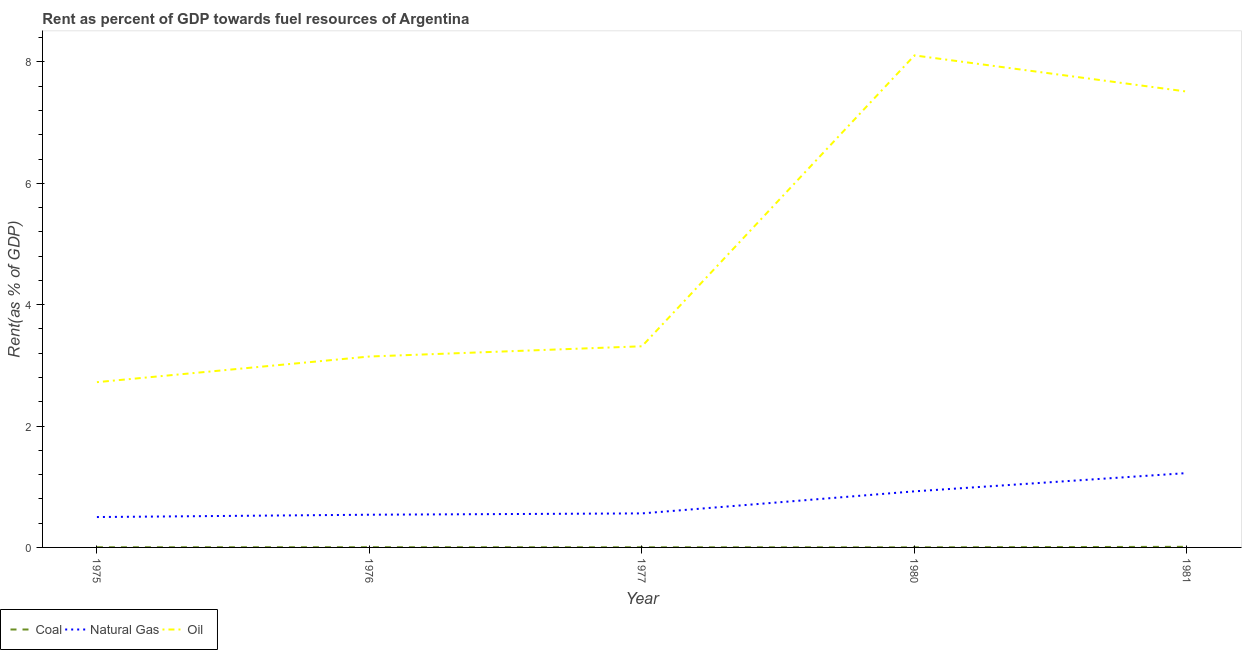What is the rent towards oil in 1981?
Offer a terse response. 7.51. Across all years, what is the maximum rent towards coal?
Offer a terse response. 0.01. Across all years, what is the minimum rent towards coal?
Ensure brevity in your answer.  0. In which year was the rent towards oil minimum?
Your answer should be very brief. 1975. What is the total rent towards coal in the graph?
Keep it short and to the point. 0.02. What is the difference between the rent towards coal in 1975 and that in 1981?
Your answer should be compact. -0.01. What is the difference between the rent towards coal in 1981 and the rent towards natural gas in 1977?
Provide a succinct answer. -0.55. What is the average rent towards oil per year?
Offer a very short reply. 4.96. In the year 1981, what is the difference between the rent towards natural gas and rent towards oil?
Your answer should be very brief. -6.29. In how many years, is the rent towards oil greater than 4.8 %?
Provide a short and direct response. 2. What is the ratio of the rent towards oil in 1977 to that in 1980?
Provide a short and direct response. 0.41. Is the difference between the rent towards oil in 1975 and 1976 greater than the difference between the rent towards coal in 1975 and 1976?
Your answer should be very brief. No. What is the difference between the highest and the second highest rent towards natural gas?
Provide a short and direct response. 0.3. What is the difference between the highest and the lowest rent towards coal?
Keep it short and to the point. 0.01. In how many years, is the rent towards coal greater than the average rent towards coal taken over all years?
Keep it short and to the point. 1. Is the sum of the rent towards natural gas in 1976 and 1980 greater than the maximum rent towards oil across all years?
Your answer should be compact. No. Does the rent towards coal monotonically increase over the years?
Offer a terse response. No. Is the rent towards coal strictly greater than the rent towards natural gas over the years?
Your response must be concise. No. How many lines are there?
Give a very brief answer. 3. What is the difference between two consecutive major ticks on the Y-axis?
Keep it short and to the point. 2. Does the graph contain any zero values?
Provide a short and direct response. No. Does the graph contain grids?
Offer a terse response. No. What is the title of the graph?
Offer a very short reply. Rent as percent of GDP towards fuel resources of Argentina. Does "Private sector" appear as one of the legend labels in the graph?
Ensure brevity in your answer.  No. What is the label or title of the X-axis?
Keep it short and to the point. Year. What is the label or title of the Y-axis?
Offer a very short reply. Rent(as % of GDP). What is the Rent(as % of GDP) in Coal in 1975?
Your answer should be compact. 0. What is the Rent(as % of GDP) of Natural Gas in 1975?
Offer a very short reply. 0.5. What is the Rent(as % of GDP) of Oil in 1975?
Offer a terse response. 2.72. What is the Rent(as % of GDP) in Coal in 1976?
Make the answer very short. 0. What is the Rent(as % of GDP) of Natural Gas in 1976?
Offer a terse response. 0.54. What is the Rent(as % of GDP) in Oil in 1976?
Provide a succinct answer. 3.15. What is the Rent(as % of GDP) of Coal in 1977?
Your response must be concise. 0. What is the Rent(as % of GDP) of Natural Gas in 1977?
Provide a short and direct response. 0.56. What is the Rent(as % of GDP) of Oil in 1977?
Give a very brief answer. 3.31. What is the Rent(as % of GDP) of Coal in 1980?
Keep it short and to the point. 0. What is the Rent(as % of GDP) in Natural Gas in 1980?
Your response must be concise. 0.92. What is the Rent(as % of GDP) in Oil in 1980?
Your response must be concise. 8.11. What is the Rent(as % of GDP) of Coal in 1981?
Ensure brevity in your answer.  0.01. What is the Rent(as % of GDP) in Natural Gas in 1981?
Make the answer very short. 1.23. What is the Rent(as % of GDP) of Oil in 1981?
Your answer should be compact. 7.51. Across all years, what is the maximum Rent(as % of GDP) of Coal?
Provide a short and direct response. 0.01. Across all years, what is the maximum Rent(as % of GDP) in Natural Gas?
Provide a short and direct response. 1.23. Across all years, what is the maximum Rent(as % of GDP) in Oil?
Give a very brief answer. 8.11. Across all years, what is the minimum Rent(as % of GDP) in Coal?
Keep it short and to the point. 0. Across all years, what is the minimum Rent(as % of GDP) of Natural Gas?
Ensure brevity in your answer.  0.5. Across all years, what is the minimum Rent(as % of GDP) of Oil?
Make the answer very short. 2.72. What is the total Rent(as % of GDP) in Coal in the graph?
Offer a terse response. 0.02. What is the total Rent(as % of GDP) in Natural Gas in the graph?
Your answer should be compact. 3.75. What is the total Rent(as % of GDP) of Oil in the graph?
Offer a very short reply. 24.8. What is the difference between the Rent(as % of GDP) of Coal in 1975 and that in 1976?
Keep it short and to the point. -0. What is the difference between the Rent(as % of GDP) of Natural Gas in 1975 and that in 1976?
Make the answer very short. -0.04. What is the difference between the Rent(as % of GDP) in Oil in 1975 and that in 1976?
Your answer should be compact. -0.42. What is the difference between the Rent(as % of GDP) of Natural Gas in 1975 and that in 1977?
Make the answer very short. -0.06. What is the difference between the Rent(as % of GDP) of Oil in 1975 and that in 1977?
Ensure brevity in your answer.  -0.59. What is the difference between the Rent(as % of GDP) in Coal in 1975 and that in 1980?
Your answer should be compact. 0. What is the difference between the Rent(as % of GDP) in Natural Gas in 1975 and that in 1980?
Keep it short and to the point. -0.42. What is the difference between the Rent(as % of GDP) of Oil in 1975 and that in 1980?
Give a very brief answer. -5.38. What is the difference between the Rent(as % of GDP) in Coal in 1975 and that in 1981?
Ensure brevity in your answer.  -0.01. What is the difference between the Rent(as % of GDP) in Natural Gas in 1975 and that in 1981?
Your response must be concise. -0.72. What is the difference between the Rent(as % of GDP) in Oil in 1975 and that in 1981?
Offer a terse response. -4.79. What is the difference between the Rent(as % of GDP) of Coal in 1976 and that in 1977?
Make the answer very short. 0. What is the difference between the Rent(as % of GDP) of Natural Gas in 1976 and that in 1977?
Provide a succinct answer. -0.02. What is the difference between the Rent(as % of GDP) in Oil in 1976 and that in 1977?
Offer a very short reply. -0.17. What is the difference between the Rent(as % of GDP) of Coal in 1976 and that in 1980?
Offer a very short reply. 0. What is the difference between the Rent(as % of GDP) of Natural Gas in 1976 and that in 1980?
Ensure brevity in your answer.  -0.39. What is the difference between the Rent(as % of GDP) of Oil in 1976 and that in 1980?
Provide a succinct answer. -4.96. What is the difference between the Rent(as % of GDP) of Coal in 1976 and that in 1981?
Provide a short and direct response. -0.01. What is the difference between the Rent(as % of GDP) in Natural Gas in 1976 and that in 1981?
Provide a short and direct response. -0.69. What is the difference between the Rent(as % of GDP) of Oil in 1976 and that in 1981?
Make the answer very short. -4.37. What is the difference between the Rent(as % of GDP) of Natural Gas in 1977 and that in 1980?
Provide a succinct answer. -0.36. What is the difference between the Rent(as % of GDP) in Oil in 1977 and that in 1980?
Your answer should be compact. -4.79. What is the difference between the Rent(as % of GDP) in Coal in 1977 and that in 1981?
Your answer should be compact. -0.01. What is the difference between the Rent(as % of GDP) in Natural Gas in 1977 and that in 1981?
Make the answer very short. -0.66. What is the difference between the Rent(as % of GDP) of Oil in 1977 and that in 1981?
Your answer should be compact. -4.2. What is the difference between the Rent(as % of GDP) of Coal in 1980 and that in 1981?
Provide a short and direct response. -0.01. What is the difference between the Rent(as % of GDP) of Natural Gas in 1980 and that in 1981?
Make the answer very short. -0.3. What is the difference between the Rent(as % of GDP) of Oil in 1980 and that in 1981?
Make the answer very short. 0.6. What is the difference between the Rent(as % of GDP) in Coal in 1975 and the Rent(as % of GDP) in Natural Gas in 1976?
Your answer should be very brief. -0.54. What is the difference between the Rent(as % of GDP) in Coal in 1975 and the Rent(as % of GDP) in Oil in 1976?
Your answer should be compact. -3.14. What is the difference between the Rent(as % of GDP) in Natural Gas in 1975 and the Rent(as % of GDP) in Oil in 1976?
Your answer should be very brief. -2.65. What is the difference between the Rent(as % of GDP) of Coal in 1975 and the Rent(as % of GDP) of Natural Gas in 1977?
Your answer should be compact. -0.56. What is the difference between the Rent(as % of GDP) of Coal in 1975 and the Rent(as % of GDP) of Oil in 1977?
Your answer should be compact. -3.31. What is the difference between the Rent(as % of GDP) of Natural Gas in 1975 and the Rent(as % of GDP) of Oil in 1977?
Offer a terse response. -2.81. What is the difference between the Rent(as % of GDP) in Coal in 1975 and the Rent(as % of GDP) in Natural Gas in 1980?
Ensure brevity in your answer.  -0.92. What is the difference between the Rent(as % of GDP) of Coal in 1975 and the Rent(as % of GDP) of Oil in 1980?
Provide a succinct answer. -8.1. What is the difference between the Rent(as % of GDP) in Natural Gas in 1975 and the Rent(as % of GDP) in Oil in 1980?
Give a very brief answer. -7.61. What is the difference between the Rent(as % of GDP) in Coal in 1975 and the Rent(as % of GDP) in Natural Gas in 1981?
Keep it short and to the point. -1.22. What is the difference between the Rent(as % of GDP) of Coal in 1975 and the Rent(as % of GDP) of Oil in 1981?
Your response must be concise. -7.51. What is the difference between the Rent(as % of GDP) in Natural Gas in 1975 and the Rent(as % of GDP) in Oil in 1981?
Provide a succinct answer. -7.01. What is the difference between the Rent(as % of GDP) in Coal in 1976 and the Rent(as % of GDP) in Natural Gas in 1977?
Make the answer very short. -0.56. What is the difference between the Rent(as % of GDP) of Coal in 1976 and the Rent(as % of GDP) of Oil in 1977?
Your answer should be compact. -3.31. What is the difference between the Rent(as % of GDP) in Natural Gas in 1976 and the Rent(as % of GDP) in Oil in 1977?
Keep it short and to the point. -2.78. What is the difference between the Rent(as % of GDP) of Coal in 1976 and the Rent(as % of GDP) of Natural Gas in 1980?
Ensure brevity in your answer.  -0.92. What is the difference between the Rent(as % of GDP) of Coal in 1976 and the Rent(as % of GDP) of Oil in 1980?
Offer a very short reply. -8.1. What is the difference between the Rent(as % of GDP) of Natural Gas in 1976 and the Rent(as % of GDP) of Oil in 1980?
Your answer should be compact. -7.57. What is the difference between the Rent(as % of GDP) of Coal in 1976 and the Rent(as % of GDP) of Natural Gas in 1981?
Your answer should be compact. -1.22. What is the difference between the Rent(as % of GDP) of Coal in 1976 and the Rent(as % of GDP) of Oil in 1981?
Offer a very short reply. -7.51. What is the difference between the Rent(as % of GDP) in Natural Gas in 1976 and the Rent(as % of GDP) in Oil in 1981?
Offer a very short reply. -6.97. What is the difference between the Rent(as % of GDP) of Coal in 1977 and the Rent(as % of GDP) of Natural Gas in 1980?
Provide a succinct answer. -0.92. What is the difference between the Rent(as % of GDP) of Coal in 1977 and the Rent(as % of GDP) of Oil in 1980?
Provide a short and direct response. -8.1. What is the difference between the Rent(as % of GDP) in Natural Gas in 1977 and the Rent(as % of GDP) in Oil in 1980?
Your response must be concise. -7.55. What is the difference between the Rent(as % of GDP) of Coal in 1977 and the Rent(as % of GDP) of Natural Gas in 1981?
Offer a very short reply. -1.22. What is the difference between the Rent(as % of GDP) of Coal in 1977 and the Rent(as % of GDP) of Oil in 1981?
Provide a short and direct response. -7.51. What is the difference between the Rent(as % of GDP) of Natural Gas in 1977 and the Rent(as % of GDP) of Oil in 1981?
Offer a terse response. -6.95. What is the difference between the Rent(as % of GDP) of Coal in 1980 and the Rent(as % of GDP) of Natural Gas in 1981?
Ensure brevity in your answer.  -1.22. What is the difference between the Rent(as % of GDP) in Coal in 1980 and the Rent(as % of GDP) in Oil in 1981?
Make the answer very short. -7.51. What is the difference between the Rent(as % of GDP) of Natural Gas in 1980 and the Rent(as % of GDP) of Oil in 1981?
Your answer should be very brief. -6.59. What is the average Rent(as % of GDP) in Coal per year?
Make the answer very short. 0. What is the average Rent(as % of GDP) of Natural Gas per year?
Ensure brevity in your answer.  0.75. What is the average Rent(as % of GDP) in Oil per year?
Provide a short and direct response. 4.96. In the year 1975, what is the difference between the Rent(as % of GDP) in Coal and Rent(as % of GDP) in Natural Gas?
Provide a short and direct response. -0.5. In the year 1975, what is the difference between the Rent(as % of GDP) of Coal and Rent(as % of GDP) of Oil?
Your answer should be very brief. -2.72. In the year 1975, what is the difference between the Rent(as % of GDP) of Natural Gas and Rent(as % of GDP) of Oil?
Keep it short and to the point. -2.22. In the year 1976, what is the difference between the Rent(as % of GDP) of Coal and Rent(as % of GDP) of Natural Gas?
Provide a short and direct response. -0.54. In the year 1976, what is the difference between the Rent(as % of GDP) of Coal and Rent(as % of GDP) of Oil?
Keep it short and to the point. -3.14. In the year 1976, what is the difference between the Rent(as % of GDP) of Natural Gas and Rent(as % of GDP) of Oil?
Keep it short and to the point. -2.61. In the year 1977, what is the difference between the Rent(as % of GDP) of Coal and Rent(as % of GDP) of Natural Gas?
Your response must be concise. -0.56. In the year 1977, what is the difference between the Rent(as % of GDP) of Coal and Rent(as % of GDP) of Oil?
Your response must be concise. -3.31. In the year 1977, what is the difference between the Rent(as % of GDP) in Natural Gas and Rent(as % of GDP) in Oil?
Ensure brevity in your answer.  -2.75. In the year 1980, what is the difference between the Rent(as % of GDP) in Coal and Rent(as % of GDP) in Natural Gas?
Your answer should be very brief. -0.92. In the year 1980, what is the difference between the Rent(as % of GDP) of Coal and Rent(as % of GDP) of Oil?
Your answer should be very brief. -8.11. In the year 1980, what is the difference between the Rent(as % of GDP) of Natural Gas and Rent(as % of GDP) of Oil?
Keep it short and to the point. -7.18. In the year 1981, what is the difference between the Rent(as % of GDP) in Coal and Rent(as % of GDP) in Natural Gas?
Offer a very short reply. -1.22. In the year 1981, what is the difference between the Rent(as % of GDP) of Coal and Rent(as % of GDP) of Oil?
Give a very brief answer. -7.5. In the year 1981, what is the difference between the Rent(as % of GDP) in Natural Gas and Rent(as % of GDP) in Oil?
Give a very brief answer. -6.29. What is the ratio of the Rent(as % of GDP) of Coal in 1975 to that in 1976?
Your response must be concise. 0.79. What is the ratio of the Rent(as % of GDP) in Natural Gas in 1975 to that in 1976?
Ensure brevity in your answer.  0.93. What is the ratio of the Rent(as % of GDP) in Oil in 1975 to that in 1976?
Your answer should be compact. 0.87. What is the ratio of the Rent(as % of GDP) in Coal in 1975 to that in 1977?
Offer a terse response. 1.13. What is the ratio of the Rent(as % of GDP) of Natural Gas in 1975 to that in 1977?
Ensure brevity in your answer.  0.89. What is the ratio of the Rent(as % of GDP) of Oil in 1975 to that in 1977?
Keep it short and to the point. 0.82. What is the ratio of the Rent(as % of GDP) of Coal in 1975 to that in 1980?
Ensure brevity in your answer.  1.75. What is the ratio of the Rent(as % of GDP) in Natural Gas in 1975 to that in 1980?
Your response must be concise. 0.54. What is the ratio of the Rent(as % of GDP) of Oil in 1975 to that in 1980?
Give a very brief answer. 0.34. What is the ratio of the Rent(as % of GDP) of Coal in 1975 to that in 1981?
Ensure brevity in your answer.  0.31. What is the ratio of the Rent(as % of GDP) in Natural Gas in 1975 to that in 1981?
Provide a short and direct response. 0.41. What is the ratio of the Rent(as % of GDP) of Oil in 1975 to that in 1981?
Make the answer very short. 0.36. What is the ratio of the Rent(as % of GDP) in Coal in 1976 to that in 1977?
Give a very brief answer. 1.43. What is the ratio of the Rent(as % of GDP) of Natural Gas in 1976 to that in 1977?
Provide a short and direct response. 0.96. What is the ratio of the Rent(as % of GDP) in Oil in 1976 to that in 1977?
Offer a very short reply. 0.95. What is the ratio of the Rent(as % of GDP) of Coal in 1976 to that in 1980?
Give a very brief answer. 2.22. What is the ratio of the Rent(as % of GDP) of Natural Gas in 1976 to that in 1980?
Your answer should be compact. 0.58. What is the ratio of the Rent(as % of GDP) of Oil in 1976 to that in 1980?
Offer a terse response. 0.39. What is the ratio of the Rent(as % of GDP) of Coal in 1976 to that in 1981?
Make the answer very short. 0.4. What is the ratio of the Rent(as % of GDP) of Natural Gas in 1976 to that in 1981?
Offer a terse response. 0.44. What is the ratio of the Rent(as % of GDP) of Oil in 1976 to that in 1981?
Keep it short and to the point. 0.42. What is the ratio of the Rent(as % of GDP) in Coal in 1977 to that in 1980?
Keep it short and to the point. 1.55. What is the ratio of the Rent(as % of GDP) in Natural Gas in 1977 to that in 1980?
Your answer should be compact. 0.61. What is the ratio of the Rent(as % of GDP) in Oil in 1977 to that in 1980?
Your response must be concise. 0.41. What is the ratio of the Rent(as % of GDP) in Coal in 1977 to that in 1981?
Provide a short and direct response. 0.28. What is the ratio of the Rent(as % of GDP) of Natural Gas in 1977 to that in 1981?
Provide a short and direct response. 0.46. What is the ratio of the Rent(as % of GDP) in Oil in 1977 to that in 1981?
Ensure brevity in your answer.  0.44. What is the ratio of the Rent(as % of GDP) of Coal in 1980 to that in 1981?
Your response must be concise. 0.18. What is the ratio of the Rent(as % of GDP) of Natural Gas in 1980 to that in 1981?
Ensure brevity in your answer.  0.75. What is the ratio of the Rent(as % of GDP) in Oil in 1980 to that in 1981?
Keep it short and to the point. 1.08. What is the difference between the highest and the second highest Rent(as % of GDP) of Coal?
Make the answer very short. 0.01. What is the difference between the highest and the second highest Rent(as % of GDP) in Natural Gas?
Your answer should be very brief. 0.3. What is the difference between the highest and the second highest Rent(as % of GDP) in Oil?
Provide a short and direct response. 0.6. What is the difference between the highest and the lowest Rent(as % of GDP) in Coal?
Offer a very short reply. 0.01. What is the difference between the highest and the lowest Rent(as % of GDP) in Natural Gas?
Give a very brief answer. 0.72. What is the difference between the highest and the lowest Rent(as % of GDP) of Oil?
Keep it short and to the point. 5.38. 